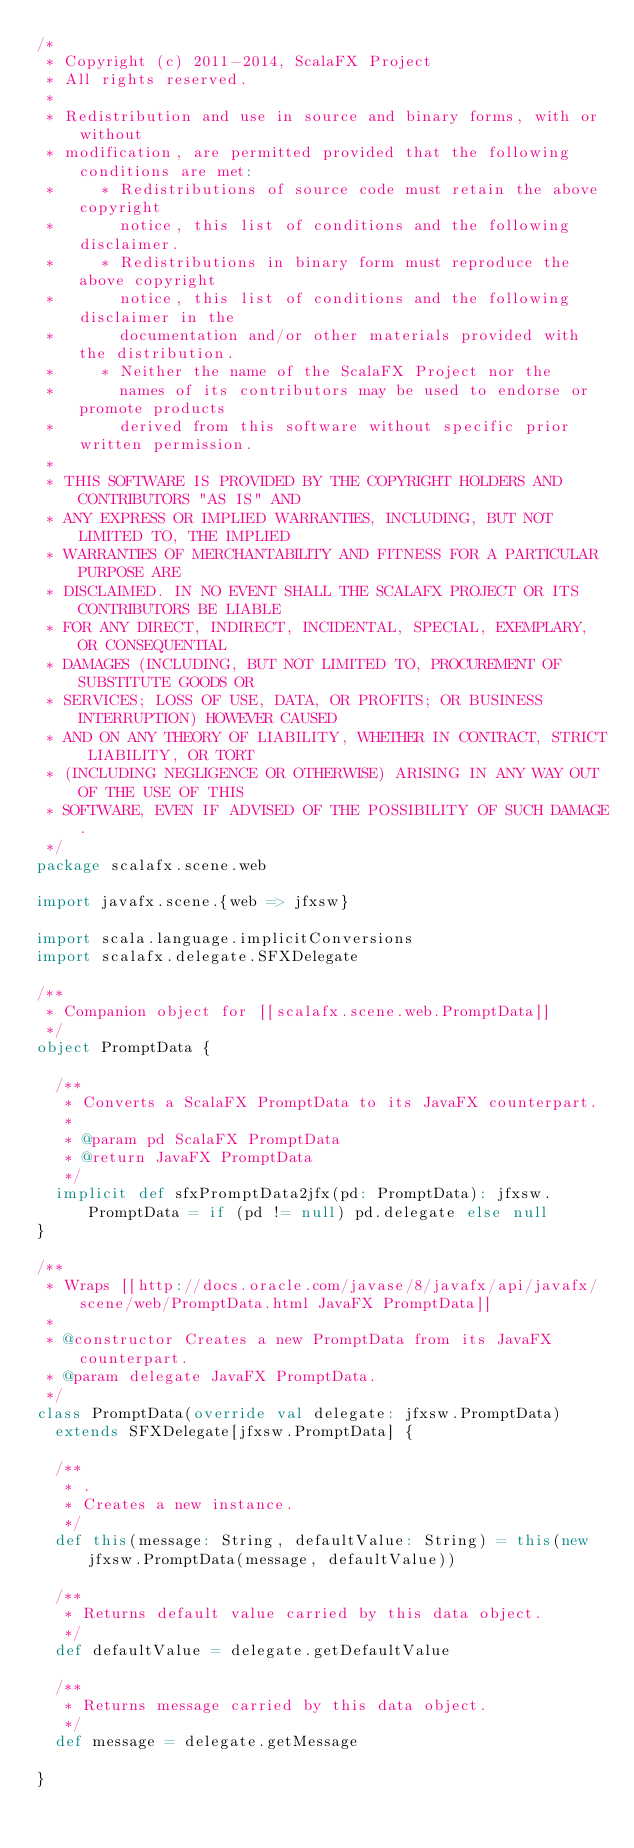Convert code to text. <code><loc_0><loc_0><loc_500><loc_500><_Scala_>/*
 * Copyright (c) 2011-2014, ScalaFX Project
 * All rights reserved.
 *
 * Redistribution and use in source and binary forms, with or without
 * modification, are permitted provided that the following conditions are met:
 *     * Redistributions of source code must retain the above copyright
 *       notice, this list of conditions and the following disclaimer.
 *     * Redistributions in binary form must reproduce the above copyright
 *       notice, this list of conditions and the following disclaimer in the
 *       documentation and/or other materials provided with the distribution.
 *     * Neither the name of the ScalaFX Project nor the
 *       names of its contributors may be used to endorse or promote products
 *       derived from this software without specific prior written permission.
 *
 * THIS SOFTWARE IS PROVIDED BY THE COPYRIGHT HOLDERS AND CONTRIBUTORS "AS IS" AND
 * ANY EXPRESS OR IMPLIED WARRANTIES, INCLUDING, BUT NOT LIMITED TO, THE IMPLIED
 * WARRANTIES OF MERCHANTABILITY AND FITNESS FOR A PARTICULAR PURPOSE ARE
 * DISCLAIMED. IN NO EVENT SHALL THE SCALAFX PROJECT OR ITS CONTRIBUTORS BE LIABLE
 * FOR ANY DIRECT, INDIRECT, INCIDENTAL, SPECIAL, EXEMPLARY, OR CONSEQUENTIAL
 * DAMAGES (INCLUDING, BUT NOT LIMITED TO, PROCUREMENT OF SUBSTITUTE GOODS OR
 * SERVICES; LOSS OF USE, DATA, OR PROFITS; OR BUSINESS INTERRUPTION) HOWEVER CAUSED
 * AND ON ANY THEORY OF LIABILITY, WHETHER IN CONTRACT, STRICT LIABILITY, OR TORT
 * (INCLUDING NEGLIGENCE OR OTHERWISE) ARISING IN ANY WAY OUT OF THE USE OF THIS
 * SOFTWARE, EVEN IF ADVISED OF THE POSSIBILITY OF SUCH DAMAGE.
 */
package scalafx.scene.web

import javafx.scene.{web => jfxsw}

import scala.language.implicitConversions
import scalafx.delegate.SFXDelegate

/**
 * Companion object for [[scalafx.scene.web.PromptData]]
 */
object PromptData {

  /**
   * Converts a ScalaFX PromptData to its JavaFX counterpart.
   *
   * @param pd ScalaFX PromptData
   * @return JavaFX PromptData
   */
  implicit def sfxPromptData2jfx(pd: PromptData): jfxsw.PromptData = if (pd != null) pd.delegate else null
}

/**
 * Wraps [[http://docs.oracle.com/javase/8/javafx/api/javafx/scene/web/PromptData.html JavaFX PromptData]]
 *
 * @constructor Creates a new PromptData from its JavaFX counterpart.
 * @param delegate JavaFX PromptData.
 */
class PromptData(override val delegate: jfxsw.PromptData)
  extends SFXDelegate[jfxsw.PromptData] {

  /**
   * .
   * Creates a new instance.
   */
  def this(message: String, defaultValue: String) = this(new jfxsw.PromptData(message, defaultValue))

  /**
   * Returns default value carried by this data object.
   */
  def defaultValue = delegate.getDefaultValue

  /**
   * Returns message carried by this data object.
   */
  def message = delegate.getMessage

}</code> 